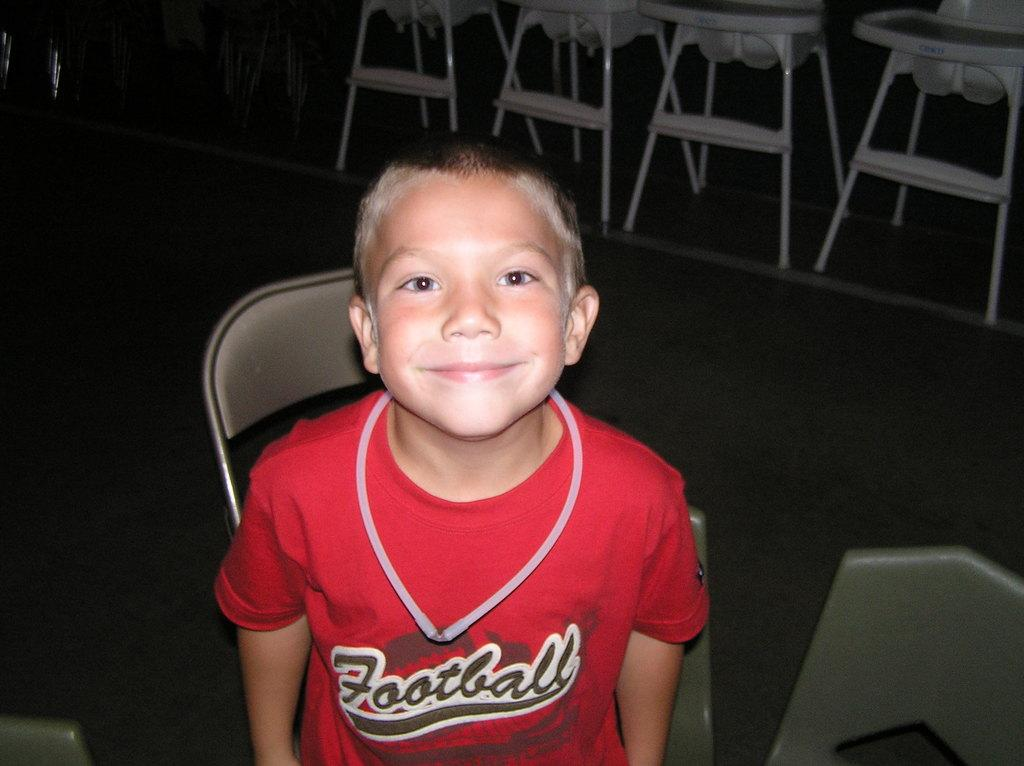What is the main subject of the image? The main subject of the image is a boy. What is the boy doing in the image? The boy is standing and smiling. Are there any objects in the image besides the boy? Yes, there is a chair in the image. What type of hose is the boy using to water the plants in the image? There is no hose or plants present in the image; it features a boy standing and smiling. Can you tell me what card game the boy is playing in the image? There is no card game or cards present in the image; it features a boy standing and smiling. 